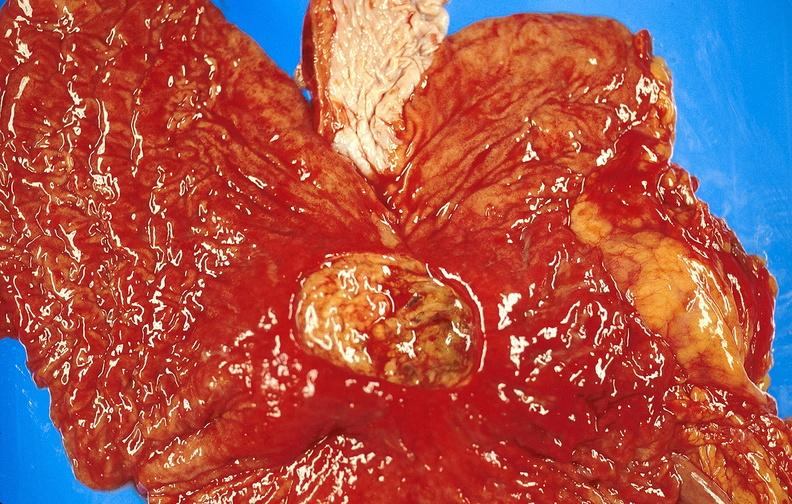what is present?
Answer the question using a single word or phrase. Gastrointestinal 